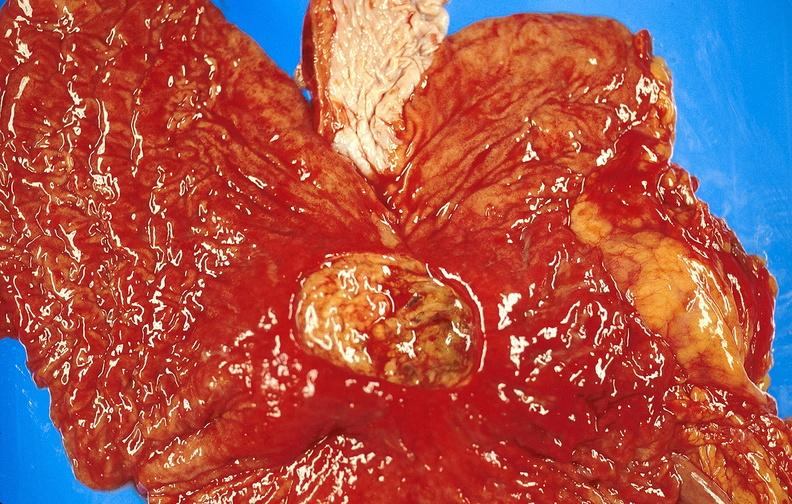what is present?
Answer the question using a single word or phrase. Gastrointestinal 